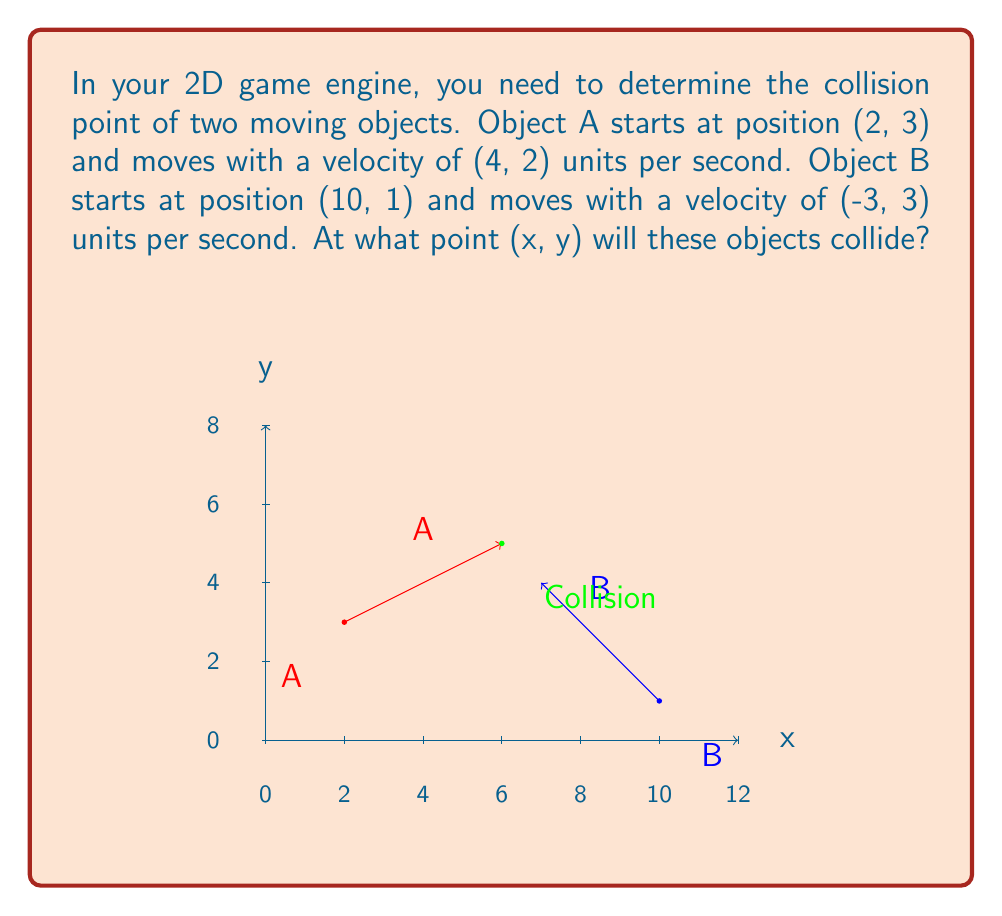Give your solution to this math problem. To solve this problem, we need to find the time when the positions of both objects are equal. Let's approach this step-by-step:

1) Let's define the position of each object as a function of time t:
   Object A: $A(t) = (2+4t, 3+2t)$
   Object B: $B(t) = (10-3t, 1+3t)$

2) At the collision point, these positions should be equal:
   $(2+4t, 3+2t) = (10-3t, 1+3t)$

3) This gives us two equations:
   $2+4t = 10-3t$
   $3+2t = 1+3t$

4) Let's solve the first equation:
   $2+4t = 10-3t$
   $7t = 8$
   $t = \frac{8}{7}$

5) We can verify this using the second equation:
   $3+2(\frac{8}{7}) = 1+3(\frac{8}{7})$
   $3+\frac{16}{7} = 1+\frac{24}{7}$
   $\frac{37}{7} = \frac{31}{7}$
   This is indeed true.

6) Now that we know t, we can substitute it back into either object's position function to find the collision point. Let's use Object A:
   $A(\frac{8}{7}) = (2+4(\frac{8}{7}), 3+2(\frac{8}{7}))$
                   $= (2+\frac{32}{7}, 3+\frac{16}{7})$
                   $= (\frac{46}{7}, \frac{37}{7})$
                   $= (6\frac{4}{7}, 5\frac{2}{7})$

Therefore, the collision point is $(\frac{46}{7}, \frac{37}{7})$ or approximately (6.57, 5.29).
Answer: $(\frac{46}{7}, \frac{37}{7})$ 